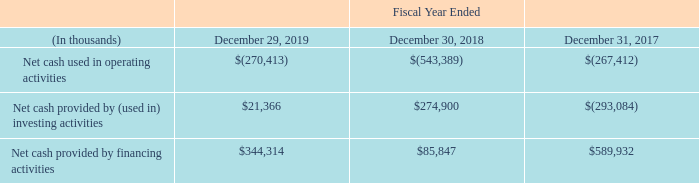Liquidity and Capital Resources
Cash Flows
A summary of the sources and uses of cash, cash equivalents, restricted cash and restricted cash equivalents is as follows:
Operating Activities
Net cash used in operating activities for the year ended December 29, 2019 was $270.4 million and was primarily the result of: (i) $158.3 million mark-to-market gain on equity investments with readily determinable fair value; (ii) $143.4 million gain on business divestiture; (iii) $128.4 million increase in inventories to support the construction of our solar energy projects; (iv) $66.2 million increase in accounts receivable, primarily driven by billings in excess of collections; (v) $38.2 million increase in contract assets driven by construction activities; (vi) $25.2 million gain on sale of assets; (vii) $17.3 million gain on sale of equity investments without readily determinable fair value; (viii) $8.9 million decrease in operating lease liabilities; (ix) $8.8 million increase in prepaid expenses and other assets, primarily related to movements in prepaid inventory; (x) net loss of $7.7 million; and (xi) $2.2 million increase in project assets, primarily related to the construction of our commercial solar energy projects. This was offset by: (i) $80.1 million depreciation and amortization; (ii) $79.3 million increase in accounts payable and other accrued liabilities; (iii) $50.2 million increase in advances to suppliers; (iv) $33.8 million loss on sale and impairment of residential lease assets; (v) $27.5 million increase in contract liabilities driven by construction activities; (vi) stock-based compensation of $26.9 million; (vii) $9.5 million non-cash interest expense; (viii) $8.6 million decrease in operating lease right-of-use assets; (ix) $7.1 million loss in equity in earnings of unconsolidated investees; (x) $5.9 million non-cash restructuring charges; and (xi) $5.0 million net change in deferred income taxes; and (xii) impairment of long-lived assets of $0.8 million.
In December 2018 and May 2019, we entered into factoring arrangements with two separate third-party factor agencies related to our accounts receivable from customers in Europe. As a result of these factoring arrangements, title of certain accounts receivable balances was transferred to third-party vendors, and both arrangements were accounted for as a sale of financial assets given effective control over these financial assets has been surrendered. As a result, these financial assets have been excluded from our consolidated balance sheets. In connection with the factoring arrangements, we sold accounts receivable invoices amounting to $119.4 million and $26.3 million in fiscal 2019 and 2018, respectively. As of December 29, 2019 and December 30, 2018, total uncollected accounts receivable from end customers under both arrangements were $11.6 million and $21.0 million, respectively.
Net cash used in operating activities in fiscal 2018 was $543.4 million and was primarily the result of: (i) net loss of $917.5 million; (ii) $182.9 million increase in long-term financing receivables related to our net investment in sales-type leases; (iii) $127.3 million decrease in accounts payable and other accrued liabilities, primarily attributable to payments of accrued expenses; (iv) $59.3 million gain on business divestiture; (v) $54.2 million gain on the sale of equity investments; (vi) $43.5 million increase in contract assets driven by construction activities; (vii) $39.2 million increase in inventories due to the support of various construction projects; (viii) $30.5 million decrease in contract liabilities driven by construction activities; (ix) $6.9 million increase in deferred income taxes; (x) $6.8 million increase due to other various activities; and (xi) $0.2 million increase in accounts receivable, primarily driven by billings. This was partially offset by: (i) impairment of property, plant and equipment of $369.2 million; (ii) impairment of residential lease assets of $189.7 million; (iii) net non-cash charges of $162.1 million related to depreciation, stock-based compensation and other non-cash charges; (iv) loss on sale of residential lease assets of $62.2 million; (v) $44.4 million decrease in advance payments made to suppliers; (vi) $39.5 million decrease in project assets, primarily related to the construction of our Commercial solar energy projects; (vii) $22.8 million decrease in prepaid expenses and other assets, primarily related to the receipt of prepaid inventory; (viii) $17.8 million decrease in equity in earnings of unconsolidated investees; (ix) $6.9 million net change in income taxes; (x) $6.4 million unrealized loss on equity investments with readily determinable fair value; and (xi) $3.9 million dividend from equity method investees.
Net cash used in operating activities in fiscal 2017 was $267.4 million and was primarily the result of: (i) net loss of $1,170.9 million; (ii) $216.3 million decrease in accounts payable and other accrued liabilities, primarily attributable to payment of accrued expenses; (iii) $123.7 million increase in long-term financing receivables related to our net investment in sales-type leases; (iv) $38.2 million increase in inventories to support the construction of our solar energy projects; (vi) $25.9 million increase in equity in earnings of unconsolidated investees; (vii) $7.0 million net change in income taxes; (viii) $5.3 million gain on sale of equity method investment; and (ix) $1.2 million decrease in accounts receivable, primarily driven by collections; This was partially offset by: (i) $624.3 million impairment of residential lease assets; (ii) other net non-cash charges of $239.6 million related to depreciation, stock-based compensation and other non-cash charges; (iii) $145.2 million increase in contract liabilities driven by construction activities; (iv) $110.5 million decrease in prepaid expenses and other assets, primarily related to the receipt of prepaid inventory; (v) $89.6 million impairment of 8point3 Energy Partners investment balance; (vi) $68.8 million decrease in advance payments made to suppliers; (vii) $30.1 million dividend from 8point3 Energy Partners; (viii) $10.7 million decrease in contract assets driven by milestone billings; (ix) $2.3 million decrease in project assets, primarily related to the construction of our commercial and power plant solar energy projects
Investing Activities
Net cash provided by investing activities in the year ended December 29, 2019 was $21.4 million, which included (i) proceeds of $60.0 million from sale of property, plant, and equipment; (ii) $42.9 million proceeds from sale of investments; (iii) net proceeds of $40.5 million from business divestiture; and (iv) $2.0 million of proceeds resulting from realization of estimated receivables from a business divestiture. This was offset by (i) cash paid for solar power systems of $53.3 million; (ii) $47.4 million of purchases of property, plant and equipment; (iii) cash paid for investments in unconsolidated investees of $12.4 million; and (iv) $10.9 million of cash de-consolidated from the sale of residential lease assets.
Net cash provided by investing activities in fiscal 2018 was $274.9 million, which included (i) proceeds from the sale of investment in joint ventures and non-public companies of $420.3 million; (ii) proceeds of $23.3 million from business divestiture; and (iii) a $13.0 million dividend from equity method investees. This was partially offset by: (i) $167.0 million in capital expenditures primarily related to the expansion of our solar cell manufacturing capacity and costs associated with solar power systems, leased and to be leased; and (ii) $14.7 million paid for investments in consolidated and unconsolidated investees.
Net cash used in investing activities in fiscal 2017 was $293.1 million, which included (i) $283.0 million in capital expenditures primarily related to the expansion of our solar cell manufacturing capacity and costs associated with solar power systems, leased and to be leased; (ii) $18.6 million paid for investments in consolidated and unconsolidated investees; and (iii) $1.3 million purchase of marketable securities. This was partially offset by proceeds from the sale of investment in joint ventures of $6.0 million and a $3.8 million dividend from equity method investees.
Financing Activities
Net cash provided by financing activities in the year ended December 29, 2019 was $344.3 million, which included: (i) $171.9 million from the common stock offering; (ii) $110.9 million in net proceeds of bank loans and other debt; (iii) $69.2 million net proceeds from the issuance of non-recourse residential financing, net of issuance costs; (iv) $35.5 million of net contributions from noncontrolling interests and redeemable noncontrolling interests related to residential lease projects; (v) $3.0 million of proceeds from issuance of non-recourse power plant and commercial financing, net of issuance costs. This was partially offset by (i) $39.0 million of payment associated with prior business combination; (ii) $5.6 million in purchases of treasury stock for tax withholding obligations on vested restricted stock; and (iii) $1.6 million settlement of contingent consideration arrangement, net of cash received.
Net cash provided by financing activities in fiscal 2018 was $85.8 million, which included: (i) $174.9 million in net proceeds from the issuance of non-recourse residential financing, net of issuance costs; (ii) $129.3 million of net contributions from noncontrolling interests and redeemable noncontrolling interests related to residential lease projects; and (iii) $94.7 million in net proceeds from the issuance of non-recourse power plant and commercial financing, net of issuance costs. This was partially offset by: (i) $307.6 million in net repayments of 0.75% debentures due 2018, bank loans and other debt; and (ii) $5.5 million in purchases of treasury stock for tax withholding obligations on vested restricted stock.
Net cash provided by financing activities in fiscal 2017 was $589.9 million, which included: (i) $351.8 million in net proceeds from the issuance of non-recourse power plant and commercial financing, net of issuance costs; (ii) $179.2 million of net contributions from noncontrolling interests and redeemable noncontrolling interests primarily related to residential lease projects; and (iii) $82.7 million in net proceeds from the issuance of non-recourse residential financing, net of issuance costs. This was partially offset by: (i) 19.1 million in net repayments of bank loans and other debt; and (ii) $4.7 million in purchases of treasury stock for tax withholding obligations on vested restricted stock.
What are the components of the sources and uses of cash, cash equivalents, restricted cash and restricted cash equivalents? Operating activities, investing activities, financing activities. What was the net cash provided by investing activities in 2017? (293,084). What was the reason for the title of certain accounts receivable balances being transferred to third-party vendors? Factoring arrangements with two separate third-party factor agencies related to our accounts receivable from customers in europe. Which year was the net cash used in operating activities the highest? $(267,412) > $(270,413) > $(543,389)
Answer: 2018. What was the change in net cash provided by investing activities from 2018 to 2019?
Answer scale should be: thousand. $21,366 - $274,900 
Answer: -253534. What is the percentage change of net cash provided by financing activities from 2017 to 2018?
Answer scale should be: percent. ($85,847 - $589,932)/$589,932 
Answer: -85.45. 